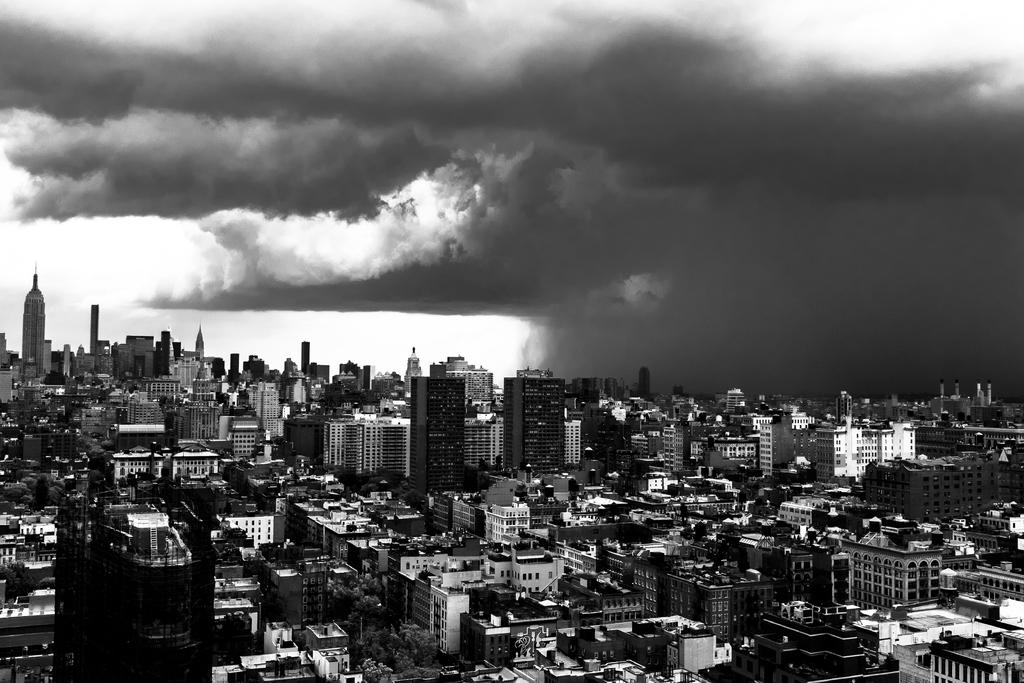What type of structures can be seen in the image? There are many buildings in the image. What part of the natural environment is visible in the image? The sky is visible at the top side of the image. Can you see a plant burning in the image? There is no plant or burning depicted in the image. Is there a tramp visible in the image? There is no tramp present in the image. 